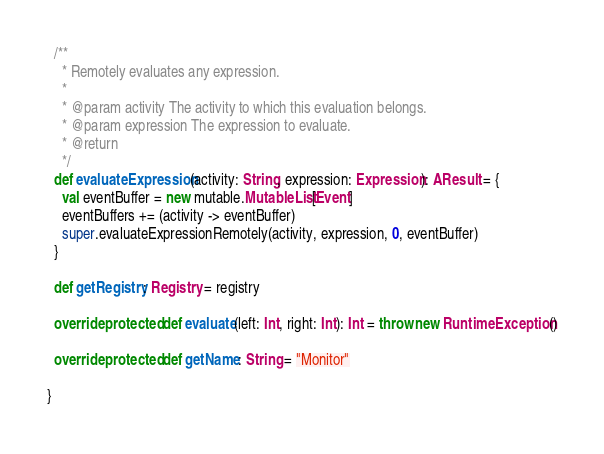<code> <loc_0><loc_0><loc_500><loc_500><_Scala_>
  /**
    * Remotely evaluates any expression.
    *
    * @param activity The activity to which this evaluation belongs.
    * @param expression The expression to evaluate.
    * @return
    */
  def evaluateExpression(activity: String, expression: Expression): AResult = {
    val eventBuffer = new mutable.MutableList[Event]
    eventBuffers += (activity -> eventBuffer)
    super.evaluateExpressionRemotely(activity, expression, 0, eventBuffer)
  }

  def getRegistry: Registry = registry

  override protected def evaluate(left: Int, right: Int): Int = throw new RuntimeException()

  override protected def getName: String = "Monitor"

}
</code> 